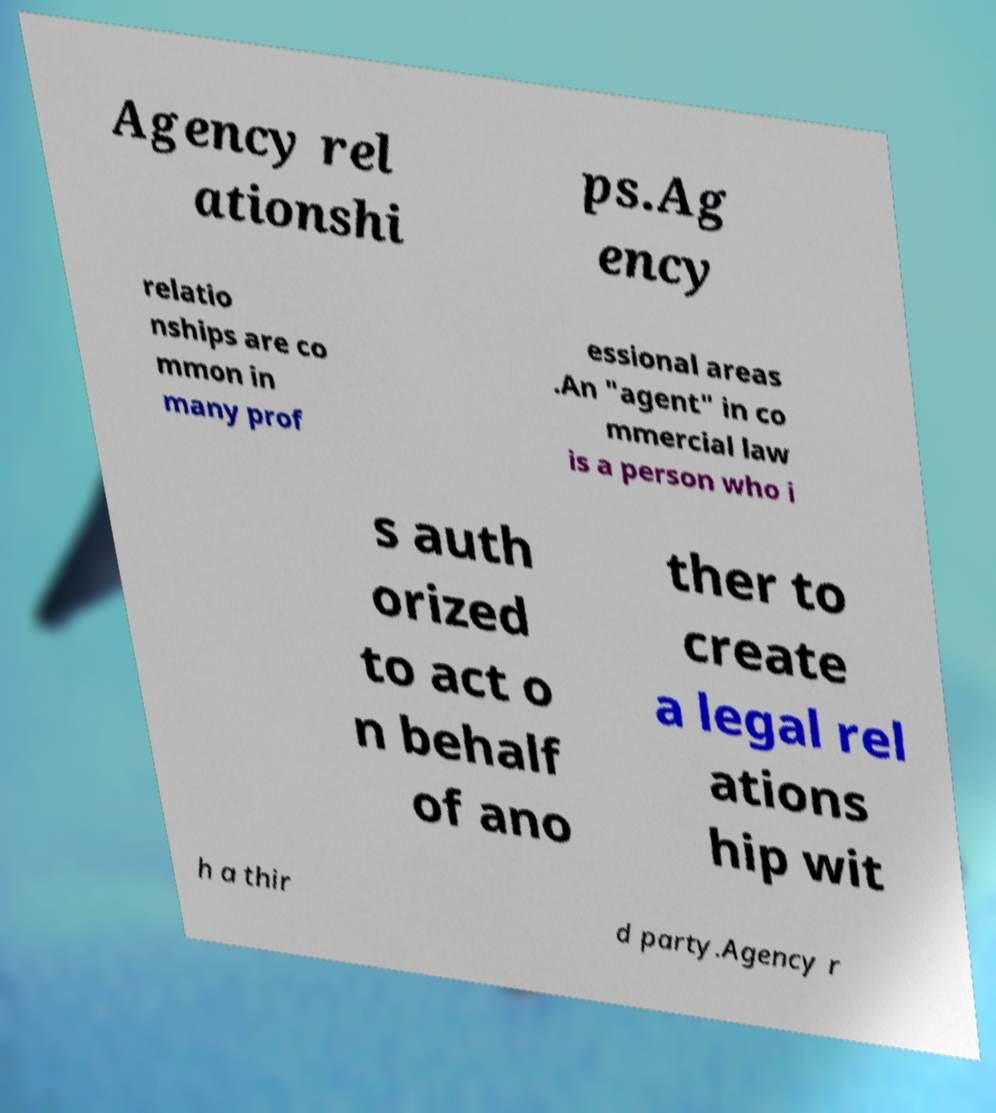Can you read and provide the text displayed in the image?This photo seems to have some interesting text. Can you extract and type it out for me? Agency rel ationshi ps.Ag ency relatio nships are co mmon in many prof essional areas .An "agent" in co mmercial law is a person who i s auth orized to act o n behalf of ano ther to create a legal rel ations hip wit h a thir d party.Agency r 